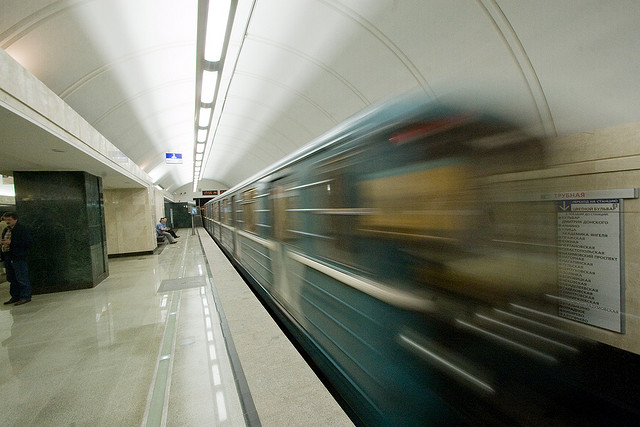How does the presence of the person on the platform enhance this image? The stillness of the individual on the platform provides a stark contrast to the blur of the moving train. It creates a narrative about the pace of life where some moments are in constant motion while others provide an opportunity for pause and reflection. It also adds a human element to the otherwise mechanical scene, highlighting the daily interactions people have with public transportation. 